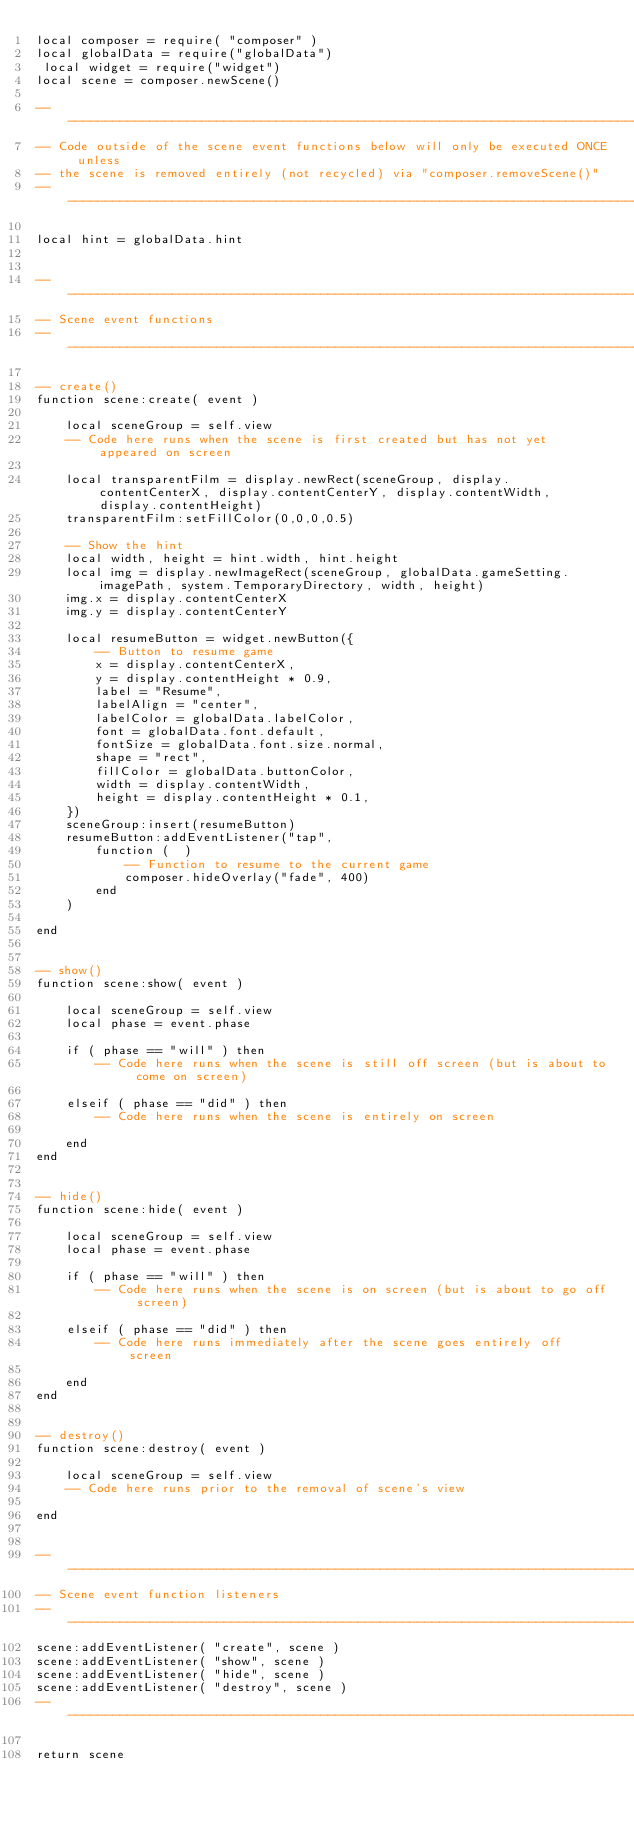Convert code to text. <code><loc_0><loc_0><loc_500><loc_500><_Lua_>local composer = require( "composer" )
local globalData = require("globalData")
 local widget = require("widget")
local scene = composer.newScene()
 
-- -----------------------------------------------------------------------------------
-- Code outside of the scene event functions below will only be executed ONCE unless
-- the scene is removed entirely (not recycled) via "composer.removeScene()"
-- -----------------------------------------------------------------------------------
 
local hint = globalData.hint
 
 
-- -----------------------------------------------------------------------------------
-- Scene event functions
-- -----------------------------------------------------------------------------------
 
-- create()
function scene:create( event )
 
    local sceneGroup = self.view
    -- Code here runs when the scene is first created but has not yet appeared on screen

    local transparentFilm = display.newRect(sceneGroup, display.contentCenterX, display.contentCenterY, display.contentWidth, display.contentHeight)
    transparentFilm:setFillColor(0,0,0,0.5)

    -- Show the hint
    local width, height = hint.width, hint.height
    local img = display.newImageRect(sceneGroup, globalData.gameSetting.imagePath, system.TemporaryDirectory, width, height)
    img.x = display.contentCenterX
    img.y = display.contentCenterY

    local resumeButton = widget.newButton({
        -- Button to resume game
        x = display.contentCenterX,
        y = display.contentHeight * 0.9,
        label = "Resume",
        labelAlign = "center",
        labelColor = globalData.labelColor,
        font = globalData.font.default,
        fontSize = globalData.font.size.normal,
        shape = "rect",
        fillColor = globalData.buttonColor,
        width = display.contentWidth,
        height = display.contentHeight * 0.1,
    })
    sceneGroup:insert(resumeButton)
    resumeButton:addEventListener("tap",
        function (  )
            -- Function to resume to the current game
            composer.hideOverlay("fade", 400)
        end
    )
 
end
 
 
-- show()
function scene:show( event )
 
    local sceneGroup = self.view
    local phase = event.phase
 
    if ( phase == "will" ) then
        -- Code here runs when the scene is still off screen (but is about to come on screen)
 
    elseif ( phase == "did" ) then
        -- Code here runs when the scene is entirely on screen
 
    end
end
 
 
-- hide()
function scene:hide( event )
 
    local sceneGroup = self.view
    local phase = event.phase
 
    if ( phase == "will" ) then
        -- Code here runs when the scene is on screen (but is about to go off screen)
 
    elseif ( phase == "did" ) then
        -- Code here runs immediately after the scene goes entirely off screen
 
    end
end
 
 
-- destroy()
function scene:destroy( event )
 
    local sceneGroup = self.view
    -- Code here runs prior to the removal of scene's view
 
end
 
 
-- -----------------------------------------------------------------------------------
-- Scene event function listeners
-- -----------------------------------------------------------------------------------
scene:addEventListener( "create", scene )
scene:addEventListener( "show", scene )
scene:addEventListener( "hide", scene )
scene:addEventListener( "destroy", scene )
-- -----------------------------------------------------------------------------------
 
return scene</code> 